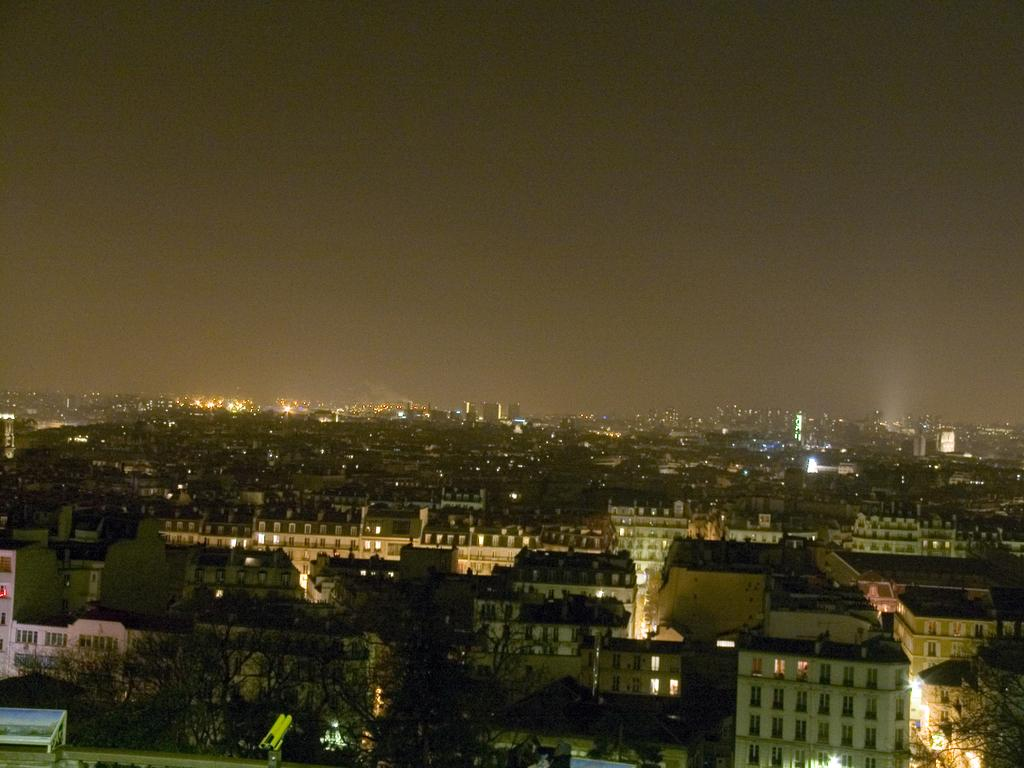What type of view is shown in the image? The image is an aerial view. What can be seen in the image from this perspective? There are many buildings and trees visible in the image. Are there any artificial light sources visible in the image? Yes, there are lights visible in the image. What is visible at the top of the image? The sky is visible at the top of the image. How many boys wearing caps can be seen climbing the rock in the image? There are no boys, caps, or rocks present in the image. 